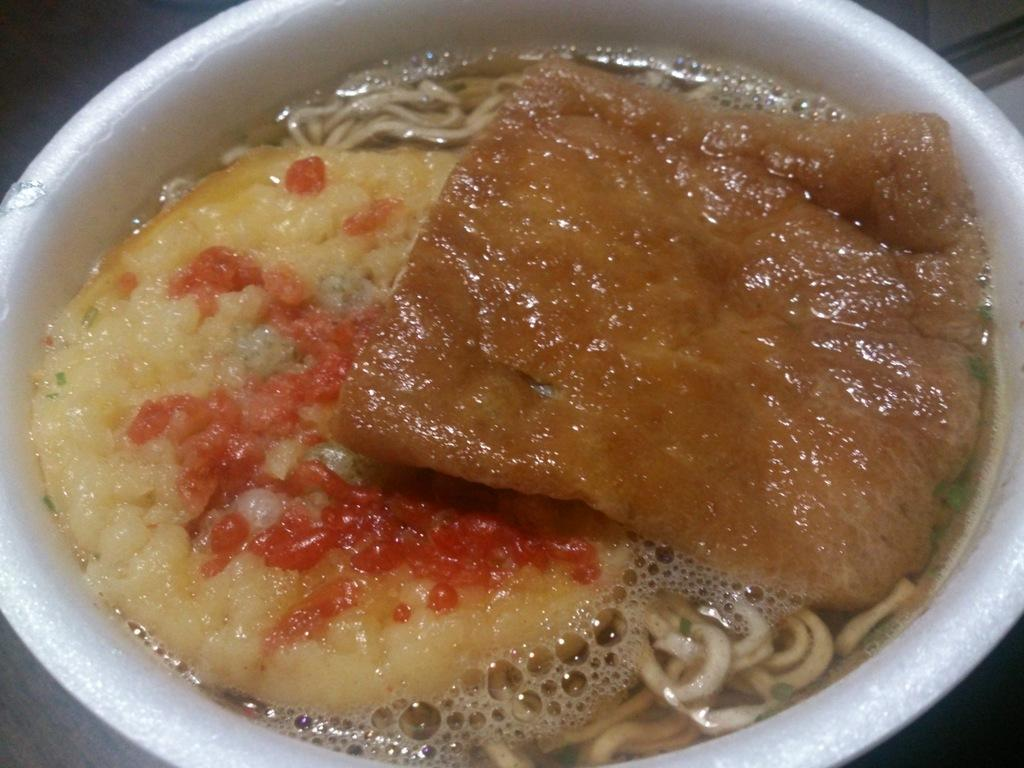What is in the bowl that is visible in the image? There is food in a bowl in the image. Where is the bowl located in the image? The bowl is placed on a surface in the image. What type of wilderness can be seen in the background of the image? There is no wilderness visible in the image; it only shows a bowl of food placed on a surface. 